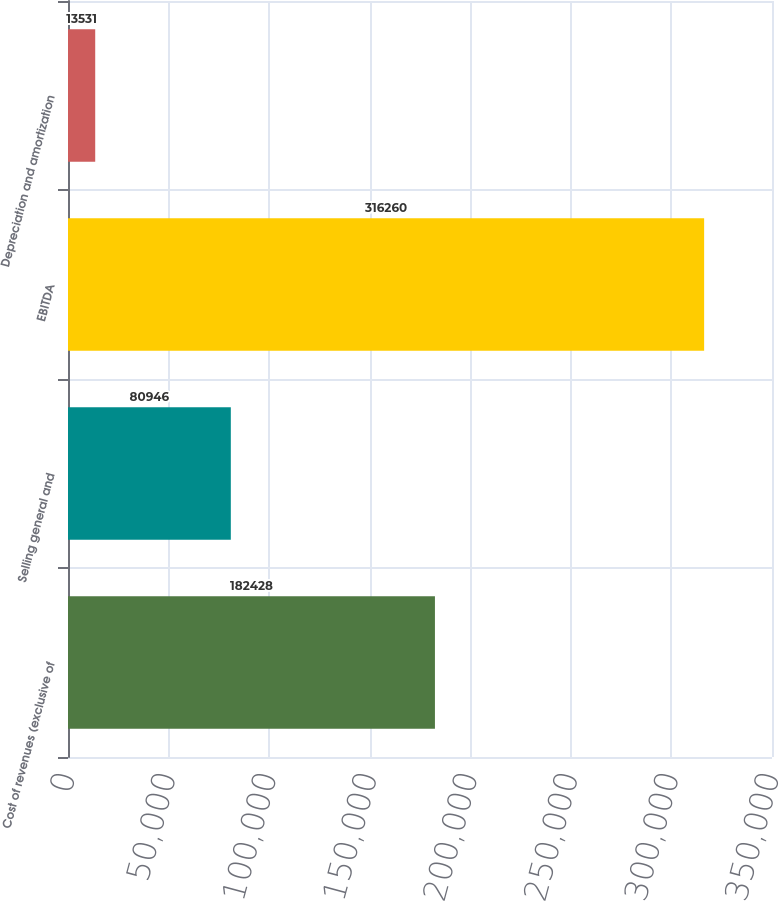Convert chart. <chart><loc_0><loc_0><loc_500><loc_500><bar_chart><fcel>Cost of revenues (exclusive of<fcel>Selling general and<fcel>EBITDA<fcel>Depreciation and amortization<nl><fcel>182428<fcel>80946<fcel>316260<fcel>13531<nl></chart> 